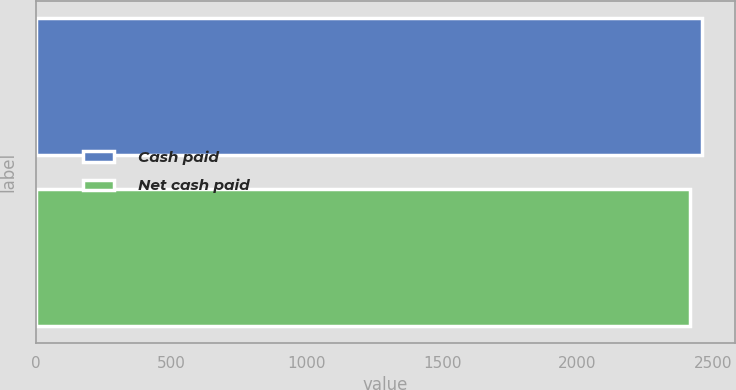Convert chart. <chart><loc_0><loc_0><loc_500><loc_500><bar_chart><fcel>Cash paid<fcel>Net cash paid<nl><fcel>2458<fcel>2413<nl></chart> 